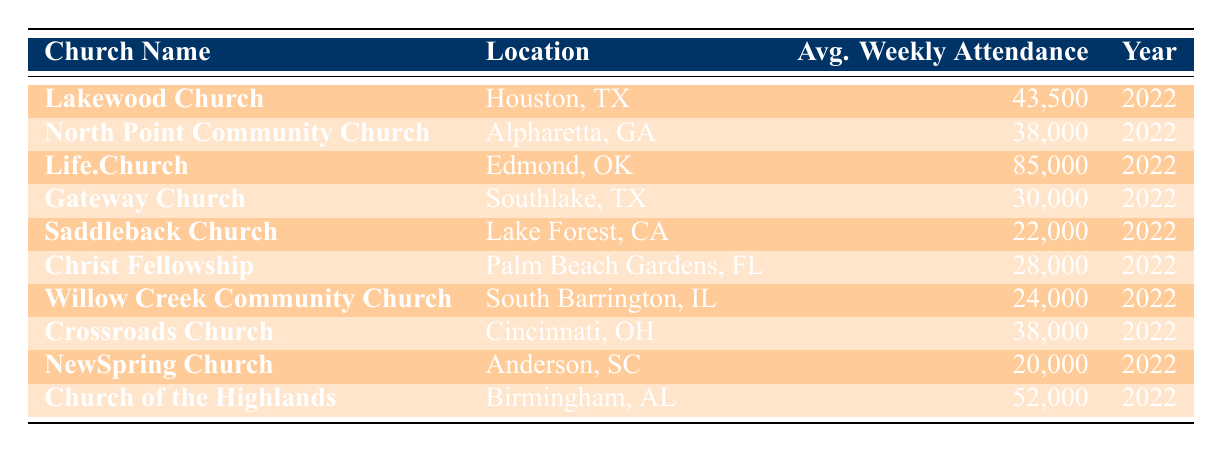What is the average weekly attendance of Life.Church? The table displays Life.Church located in Edmond, OK, with an average weekly attendance listed as 85,000 for the year 2022.
Answer: 85,000 Which church has the lowest average weekly attendance? Upon examining the attendance figures in the table, NewSpring Church in Anderson, SC has the lowest attendance of 20,000 for the year 2022.
Answer: NewSpring Church What is the total average weekly attendance for the churches located in Texas? The Texas churches listed are Lakewood Church (43,500), Gateway Church (30,000), and Saddleback Church (22,000). Adding these numbers gives 43,500 + 30,000 + 22,000 = 95,500 as the total average weekly attendance for Texas.
Answer: 95,500 Is the average attendance of North Point Community Church greater than that of Willow Creek Community Church? North Point Community Church has an average attendance of 38,000, while Willow Creek Community Church has 24,000. Since 38,000 is greater than 24,000, the answer is yes.
Answer: Yes What is the difference in average weekly attendance between the church with the highest and the church with the lowest attendance? The highest average attendance is from Life.Church at 85,000, and the lowest is NewSpring Church at 20,000. Calculating the difference: 85,000 - 20,000 = 65,000.
Answer: 65,000 How many churches have an average weekly attendance of more than 30,000? From the table, the churches with more than 30,000 attendance are Lakewood Church (43,500), Life.Church (85,000), Church of the Highlands (52,000), and North Point Community Church (38,000), totaling four churches.
Answer: 4 What is the average attendance of churches located in the Southeast United States? The churches located in the Southeast are Church of the Highlands (52,000), Christ Fellowship (28,000), and NewSpring Church (20,000). Adding their attendances, we get: 52,000 + 28,000 + 20,000 = 100,000. Dividing this by 3 churches gives an average of 100,000 / 3 ≈ 33,333.
Answer: 33,333 Which state has the church with the highest attendance, and what is the attendance figure? Life.Church in Oklahoma has the highest attendance figure of 85,000.
Answer: Oklahoma; 85,000 Are there any churches with an average weekly attendance of 30,000 or more exclusive to California? Saddleback Church is in California and has an average attendance of 22,000, which is less than 30,000. Thus, no church in California has an attendance of 30,000 or more.
Answer: No 